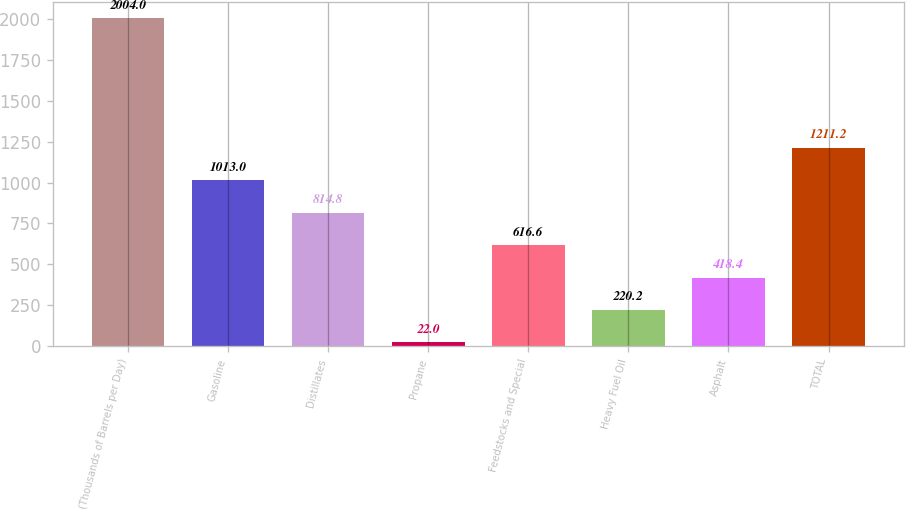Convert chart to OTSL. <chart><loc_0><loc_0><loc_500><loc_500><bar_chart><fcel>(Thousands of Barrels per Day)<fcel>Gasoline<fcel>Distillates<fcel>Propane<fcel>Feedstocks and Special<fcel>Heavy Fuel Oil<fcel>Asphalt<fcel>TOTAL<nl><fcel>2004<fcel>1013<fcel>814.8<fcel>22<fcel>616.6<fcel>220.2<fcel>418.4<fcel>1211.2<nl></chart> 